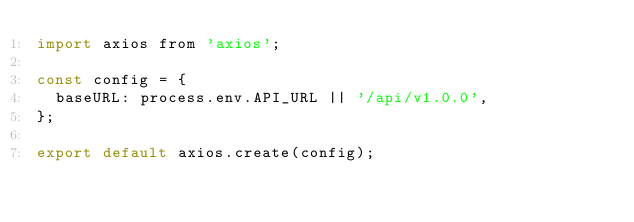Convert code to text. <code><loc_0><loc_0><loc_500><loc_500><_JavaScript_>import axios from 'axios';

const config = {
  baseURL: process.env.API_URL || '/api/v1.0.0',
};

export default axios.create(config);
</code> 